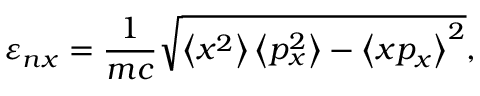<formula> <loc_0><loc_0><loc_500><loc_500>\varepsilon _ { n x } = \frac { 1 } { m c } \sqrt { \left < x ^ { 2 } \right > \left < p _ { x } ^ { 2 } \right > - \left < x p _ { x } \right > ^ { 2 } } ,</formula> 